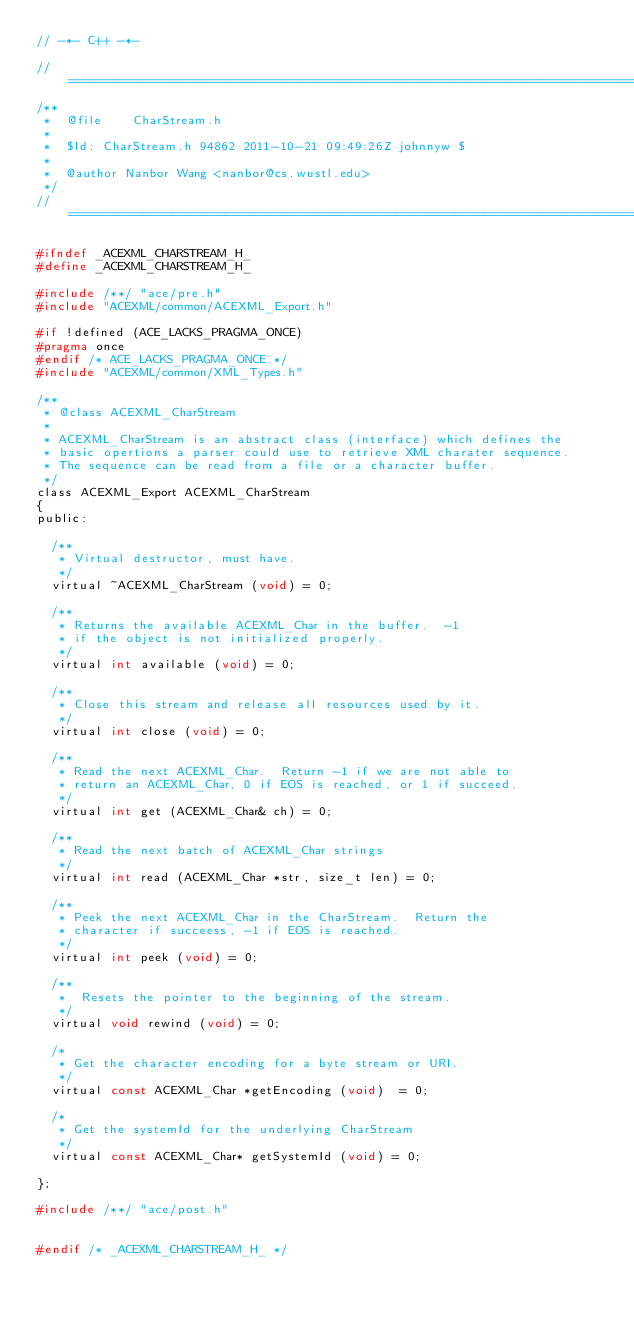<code> <loc_0><loc_0><loc_500><loc_500><_C_>// -*- C++ -*-

//=============================================================================
/**
 *  @file    CharStream.h
 *
 *  $Id: CharStream.h 94862 2011-10-21 09:49:26Z johnnyw $
 *
 *  @author Nanbor Wang <nanbor@cs.wustl.edu>
 */
//=============================================================================

#ifndef _ACEXML_CHARSTREAM_H_
#define _ACEXML_CHARSTREAM_H_

#include /**/ "ace/pre.h"
#include "ACEXML/common/ACEXML_Export.h"

#if !defined (ACE_LACKS_PRAGMA_ONCE)
#pragma once
#endif /* ACE_LACKS_PRAGMA_ONCE */
#include "ACEXML/common/XML_Types.h"

/**
 * @class ACEXML_CharStream
 *
 * ACEXML_CharStream is an abstract class (interface) which defines the
 * basic opertions a parser could use to retrieve XML charater sequence.
 * The sequence can be read from a file or a character buffer.
 */
class ACEXML_Export ACEXML_CharStream
{
public:

  /**
   * Virtual destructor, must have.
   */
  virtual ~ACEXML_CharStream (void) = 0;

  /**
   * Returns the available ACEXML_Char in the buffer.  -1
   * if the object is not initialized properly.
   */
  virtual int available (void) = 0;

  /**
   * Close this stream and release all resources used by it.
   */
  virtual int close (void) = 0;

  /**
   * Read the next ACEXML_Char.  Return -1 if we are not able to
   * return an ACEXML_Char, 0 if EOS is reached, or 1 if succeed.
   */
  virtual int get (ACEXML_Char& ch) = 0;

  /**
   * Read the next batch of ACEXML_Char strings
   */
  virtual int read (ACEXML_Char *str, size_t len) = 0;

  /**
   * Peek the next ACEXML_Char in the CharStream.  Return the
   * character if succeess, -1 if EOS is reached.
   */
  virtual int peek (void) = 0;

  /**
   *  Resets the pointer to the beginning of the stream.
   */
  virtual void rewind (void) = 0;

  /*
   * Get the character encoding for a byte stream or URI.
   */
  virtual const ACEXML_Char *getEncoding (void)  = 0;

  /*
   * Get the systemId for the underlying CharStream
   */
  virtual const ACEXML_Char* getSystemId (void) = 0;

};

#include /**/ "ace/post.h"


#endif /* _ACEXML_CHARSTREAM_H_ */
</code> 